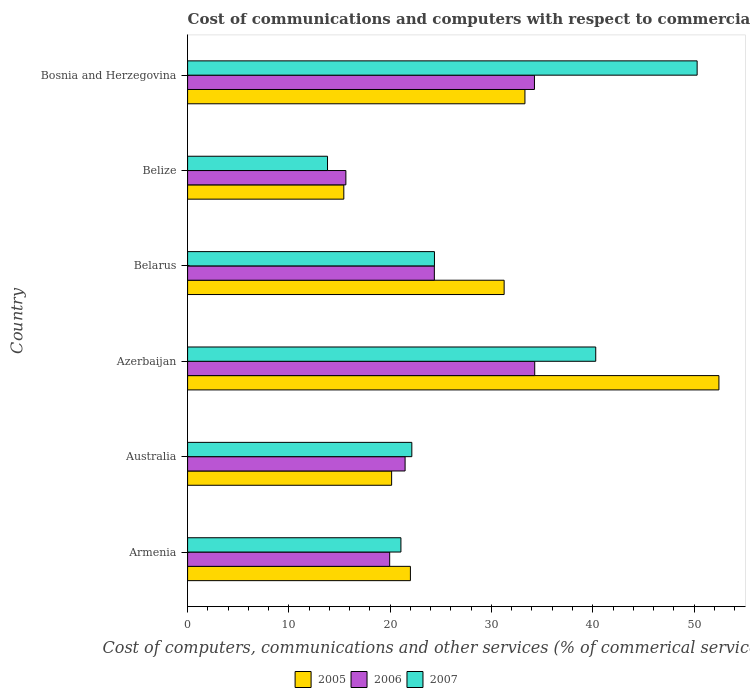How many groups of bars are there?
Offer a terse response. 6. Are the number of bars on each tick of the Y-axis equal?
Ensure brevity in your answer.  Yes. How many bars are there on the 5th tick from the bottom?
Your answer should be very brief. 3. What is the label of the 2nd group of bars from the top?
Make the answer very short. Belize. What is the cost of communications and computers in 2007 in Azerbaijan?
Keep it short and to the point. 40.29. Across all countries, what is the maximum cost of communications and computers in 2006?
Give a very brief answer. 34.27. Across all countries, what is the minimum cost of communications and computers in 2005?
Provide a short and direct response. 15.42. In which country was the cost of communications and computers in 2007 maximum?
Provide a succinct answer. Bosnia and Herzegovina. In which country was the cost of communications and computers in 2006 minimum?
Offer a very short reply. Belize. What is the total cost of communications and computers in 2006 in the graph?
Provide a short and direct response. 149.92. What is the difference between the cost of communications and computers in 2006 in Belize and that in Bosnia and Herzegovina?
Provide a short and direct response. -18.62. What is the difference between the cost of communications and computers in 2005 in Belize and the cost of communications and computers in 2006 in Armenia?
Offer a very short reply. -4.53. What is the average cost of communications and computers in 2006 per country?
Provide a short and direct response. 24.99. What is the difference between the cost of communications and computers in 2007 and cost of communications and computers in 2006 in Armenia?
Keep it short and to the point. 1.11. In how many countries, is the cost of communications and computers in 2007 greater than 18 %?
Your answer should be very brief. 5. What is the ratio of the cost of communications and computers in 2006 in Armenia to that in Bosnia and Herzegovina?
Give a very brief answer. 0.58. What is the difference between the highest and the second highest cost of communications and computers in 2006?
Provide a short and direct response. 0.03. What is the difference between the highest and the lowest cost of communications and computers in 2006?
Make the answer very short. 18.64. What does the 1st bar from the top in Australia represents?
Your answer should be very brief. 2007. What does the 1st bar from the bottom in Bosnia and Herzegovina represents?
Offer a terse response. 2005. Is it the case that in every country, the sum of the cost of communications and computers in 2005 and cost of communications and computers in 2007 is greater than the cost of communications and computers in 2006?
Keep it short and to the point. Yes. How many countries are there in the graph?
Your answer should be very brief. 6. What is the difference between two consecutive major ticks on the X-axis?
Ensure brevity in your answer.  10. Does the graph contain any zero values?
Give a very brief answer. No. Where does the legend appear in the graph?
Keep it short and to the point. Bottom center. What is the title of the graph?
Your answer should be very brief. Cost of communications and computers with respect to commercial service exports. Does "1963" appear as one of the legend labels in the graph?
Offer a terse response. No. What is the label or title of the X-axis?
Give a very brief answer. Cost of computers, communications and other services (% of commerical service exports). What is the label or title of the Y-axis?
Provide a short and direct response. Country. What is the Cost of computers, communications and other services (% of commerical service exports) in 2005 in Armenia?
Give a very brief answer. 22. What is the Cost of computers, communications and other services (% of commerical service exports) in 2006 in Armenia?
Your response must be concise. 19.95. What is the Cost of computers, communications and other services (% of commerical service exports) in 2007 in Armenia?
Ensure brevity in your answer.  21.06. What is the Cost of computers, communications and other services (% of commerical service exports) of 2005 in Australia?
Make the answer very short. 20.14. What is the Cost of computers, communications and other services (% of commerical service exports) in 2006 in Australia?
Give a very brief answer. 21.47. What is the Cost of computers, communications and other services (% of commerical service exports) in 2007 in Australia?
Provide a short and direct response. 22.14. What is the Cost of computers, communications and other services (% of commerical service exports) of 2005 in Azerbaijan?
Provide a short and direct response. 52.45. What is the Cost of computers, communications and other services (% of commerical service exports) of 2006 in Azerbaijan?
Make the answer very short. 34.27. What is the Cost of computers, communications and other services (% of commerical service exports) of 2007 in Azerbaijan?
Offer a terse response. 40.29. What is the Cost of computers, communications and other services (% of commerical service exports) in 2005 in Belarus?
Keep it short and to the point. 31.25. What is the Cost of computers, communications and other services (% of commerical service exports) in 2006 in Belarus?
Give a very brief answer. 24.36. What is the Cost of computers, communications and other services (% of commerical service exports) of 2007 in Belarus?
Your response must be concise. 24.37. What is the Cost of computers, communications and other services (% of commerical service exports) of 2005 in Belize?
Offer a terse response. 15.42. What is the Cost of computers, communications and other services (% of commerical service exports) in 2006 in Belize?
Keep it short and to the point. 15.63. What is the Cost of computers, communications and other services (% of commerical service exports) in 2007 in Belize?
Offer a terse response. 13.81. What is the Cost of computers, communications and other services (% of commerical service exports) in 2005 in Bosnia and Herzegovina?
Give a very brief answer. 33.3. What is the Cost of computers, communications and other services (% of commerical service exports) of 2006 in Bosnia and Herzegovina?
Your answer should be compact. 34.24. What is the Cost of computers, communications and other services (% of commerical service exports) of 2007 in Bosnia and Herzegovina?
Provide a succinct answer. 50.3. Across all countries, what is the maximum Cost of computers, communications and other services (% of commerical service exports) of 2005?
Keep it short and to the point. 52.45. Across all countries, what is the maximum Cost of computers, communications and other services (% of commerical service exports) of 2006?
Provide a succinct answer. 34.27. Across all countries, what is the maximum Cost of computers, communications and other services (% of commerical service exports) of 2007?
Provide a succinct answer. 50.3. Across all countries, what is the minimum Cost of computers, communications and other services (% of commerical service exports) in 2005?
Offer a very short reply. 15.42. Across all countries, what is the minimum Cost of computers, communications and other services (% of commerical service exports) of 2006?
Make the answer very short. 15.63. Across all countries, what is the minimum Cost of computers, communications and other services (% of commerical service exports) of 2007?
Your answer should be very brief. 13.81. What is the total Cost of computers, communications and other services (% of commerical service exports) in 2005 in the graph?
Your response must be concise. 174.57. What is the total Cost of computers, communications and other services (% of commerical service exports) of 2006 in the graph?
Your response must be concise. 149.92. What is the total Cost of computers, communications and other services (% of commerical service exports) of 2007 in the graph?
Provide a short and direct response. 171.98. What is the difference between the Cost of computers, communications and other services (% of commerical service exports) of 2005 in Armenia and that in Australia?
Offer a terse response. 1.85. What is the difference between the Cost of computers, communications and other services (% of commerical service exports) in 2006 in Armenia and that in Australia?
Ensure brevity in your answer.  -1.52. What is the difference between the Cost of computers, communications and other services (% of commerical service exports) of 2007 in Armenia and that in Australia?
Keep it short and to the point. -1.08. What is the difference between the Cost of computers, communications and other services (% of commerical service exports) of 2005 in Armenia and that in Azerbaijan?
Offer a terse response. -30.46. What is the difference between the Cost of computers, communications and other services (% of commerical service exports) of 2006 in Armenia and that in Azerbaijan?
Provide a succinct answer. -14.32. What is the difference between the Cost of computers, communications and other services (% of commerical service exports) in 2007 in Armenia and that in Azerbaijan?
Your answer should be very brief. -19.23. What is the difference between the Cost of computers, communications and other services (% of commerical service exports) of 2005 in Armenia and that in Belarus?
Your answer should be very brief. -9.25. What is the difference between the Cost of computers, communications and other services (% of commerical service exports) of 2006 in Armenia and that in Belarus?
Offer a very short reply. -4.41. What is the difference between the Cost of computers, communications and other services (% of commerical service exports) in 2007 in Armenia and that in Belarus?
Your answer should be compact. -3.31. What is the difference between the Cost of computers, communications and other services (% of commerical service exports) of 2005 in Armenia and that in Belize?
Give a very brief answer. 6.57. What is the difference between the Cost of computers, communications and other services (% of commerical service exports) in 2006 in Armenia and that in Belize?
Provide a short and direct response. 4.32. What is the difference between the Cost of computers, communications and other services (% of commerical service exports) in 2007 in Armenia and that in Belize?
Provide a short and direct response. 7.25. What is the difference between the Cost of computers, communications and other services (% of commerical service exports) of 2005 in Armenia and that in Bosnia and Herzegovina?
Keep it short and to the point. -11.31. What is the difference between the Cost of computers, communications and other services (% of commerical service exports) of 2006 in Armenia and that in Bosnia and Herzegovina?
Your answer should be very brief. -14.29. What is the difference between the Cost of computers, communications and other services (% of commerical service exports) in 2007 in Armenia and that in Bosnia and Herzegovina?
Give a very brief answer. -29.24. What is the difference between the Cost of computers, communications and other services (% of commerical service exports) of 2005 in Australia and that in Azerbaijan?
Provide a short and direct response. -32.31. What is the difference between the Cost of computers, communications and other services (% of commerical service exports) of 2006 in Australia and that in Azerbaijan?
Provide a succinct answer. -12.8. What is the difference between the Cost of computers, communications and other services (% of commerical service exports) in 2007 in Australia and that in Azerbaijan?
Keep it short and to the point. -18.16. What is the difference between the Cost of computers, communications and other services (% of commerical service exports) in 2005 in Australia and that in Belarus?
Your answer should be very brief. -11.11. What is the difference between the Cost of computers, communications and other services (% of commerical service exports) of 2006 in Australia and that in Belarus?
Provide a succinct answer. -2.89. What is the difference between the Cost of computers, communications and other services (% of commerical service exports) of 2007 in Australia and that in Belarus?
Give a very brief answer. -2.23. What is the difference between the Cost of computers, communications and other services (% of commerical service exports) of 2005 in Australia and that in Belize?
Keep it short and to the point. 4.72. What is the difference between the Cost of computers, communications and other services (% of commerical service exports) in 2006 in Australia and that in Belize?
Your response must be concise. 5.85. What is the difference between the Cost of computers, communications and other services (% of commerical service exports) of 2007 in Australia and that in Belize?
Provide a succinct answer. 8.32. What is the difference between the Cost of computers, communications and other services (% of commerical service exports) in 2005 in Australia and that in Bosnia and Herzegovina?
Give a very brief answer. -13.16. What is the difference between the Cost of computers, communications and other services (% of commerical service exports) of 2006 in Australia and that in Bosnia and Herzegovina?
Provide a succinct answer. -12.77. What is the difference between the Cost of computers, communications and other services (% of commerical service exports) of 2007 in Australia and that in Bosnia and Herzegovina?
Provide a succinct answer. -28.17. What is the difference between the Cost of computers, communications and other services (% of commerical service exports) in 2005 in Azerbaijan and that in Belarus?
Your answer should be compact. 21.2. What is the difference between the Cost of computers, communications and other services (% of commerical service exports) in 2006 in Azerbaijan and that in Belarus?
Your response must be concise. 9.91. What is the difference between the Cost of computers, communications and other services (% of commerical service exports) in 2007 in Azerbaijan and that in Belarus?
Keep it short and to the point. 15.92. What is the difference between the Cost of computers, communications and other services (% of commerical service exports) of 2005 in Azerbaijan and that in Belize?
Your response must be concise. 37.03. What is the difference between the Cost of computers, communications and other services (% of commerical service exports) in 2006 in Azerbaijan and that in Belize?
Keep it short and to the point. 18.64. What is the difference between the Cost of computers, communications and other services (% of commerical service exports) of 2007 in Azerbaijan and that in Belize?
Make the answer very short. 26.48. What is the difference between the Cost of computers, communications and other services (% of commerical service exports) of 2005 in Azerbaijan and that in Bosnia and Herzegovina?
Your answer should be compact. 19.15. What is the difference between the Cost of computers, communications and other services (% of commerical service exports) of 2006 in Azerbaijan and that in Bosnia and Herzegovina?
Make the answer very short. 0.03. What is the difference between the Cost of computers, communications and other services (% of commerical service exports) of 2007 in Azerbaijan and that in Bosnia and Herzegovina?
Give a very brief answer. -10.01. What is the difference between the Cost of computers, communications and other services (% of commerical service exports) in 2005 in Belarus and that in Belize?
Make the answer very short. 15.83. What is the difference between the Cost of computers, communications and other services (% of commerical service exports) of 2006 in Belarus and that in Belize?
Offer a terse response. 8.73. What is the difference between the Cost of computers, communications and other services (% of commerical service exports) in 2007 in Belarus and that in Belize?
Provide a succinct answer. 10.56. What is the difference between the Cost of computers, communications and other services (% of commerical service exports) of 2005 in Belarus and that in Bosnia and Herzegovina?
Your answer should be compact. -2.05. What is the difference between the Cost of computers, communications and other services (% of commerical service exports) of 2006 in Belarus and that in Bosnia and Herzegovina?
Ensure brevity in your answer.  -9.88. What is the difference between the Cost of computers, communications and other services (% of commerical service exports) of 2007 in Belarus and that in Bosnia and Herzegovina?
Provide a short and direct response. -25.93. What is the difference between the Cost of computers, communications and other services (% of commerical service exports) of 2005 in Belize and that in Bosnia and Herzegovina?
Give a very brief answer. -17.88. What is the difference between the Cost of computers, communications and other services (% of commerical service exports) of 2006 in Belize and that in Bosnia and Herzegovina?
Your answer should be very brief. -18.62. What is the difference between the Cost of computers, communications and other services (% of commerical service exports) in 2007 in Belize and that in Bosnia and Herzegovina?
Offer a very short reply. -36.49. What is the difference between the Cost of computers, communications and other services (% of commerical service exports) of 2005 in Armenia and the Cost of computers, communications and other services (% of commerical service exports) of 2006 in Australia?
Provide a succinct answer. 0.52. What is the difference between the Cost of computers, communications and other services (% of commerical service exports) of 2005 in Armenia and the Cost of computers, communications and other services (% of commerical service exports) of 2007 in Australia?
Make the answer very short. -0.14. What is the difference between the Cost of computers, communications and other services (% of commerical service exports) in 2006 in Armenia and the Cost of computers, communications and other services (% of commerical service exports) in 2007 in Australia?
Give a very brief answer. -2.19. What is the difference between the Cost of computers, communications and other services (% of commerical service exports) in 2005 in Armenia and the Cost of computers, communications and other services (% of commerical service exports) in 2006 in Azerbaijan?
Provide a succinct answer. -12.27. What is the difference between the Cost of computers, communications and other services (% of commerical service exports) in 2005 in Armenia and the Cost of computers, communications and other services (% of commerical service exports) in 2007 in Azerbaijan?
Offer a terse response. -18.3. What is the difference between the Cost of computers, communications and other services (% of commerical service exports) in 2006 in Armenia and the Cost of computers, communications and other services (% of commerical service exports) in 2007 in Azerbaijan?
Provide a succinct answer. -20.34. What is the difference between the Cost of computers, communications and other services (% of commerical service exports) in 2005 in Armenia and the Cost of computers, communications and other services (% of commerical service exports) in 2006 in Belarus?
Your answer should be very brief. -2.36. What is the difference between the Cost of computers, communications and other services (% of commerical service exports) in 2005 in Armenia and the Cost of computers, communications and other services (% of commerical service exports) in 2007 in Belarus?
Offer a terse response. -2.37. What is the difference between the Cost of computers, communications and other services (% of commerical service exports) of 2006 in Armenia and the Cost of computers, communications and other services (% of commerical service exports) of 2007 in Belarus?
Provide a succinct answer. -4.42. What is the difference between the Cost of computers, communications and other services (% of commerical service exports) of 2005 in Armenia and the Cost of computers, communications and other services (% of commerical service exports) of 2006 in Belize?
Keep it short and to the point. 6.37. What is the difference between the Cost of computers, communications and other services (% of commerical service exports) in 2005 in Armenia and the Cost of computers, communications and other services (% of commerical service exports) in 2007 in Belize?
Keep it short and to the point. 8.18. What is the difference between the Cost of computers, communications and other services (% of commerical service exports) in 2006 in Armenia and the Cost of computers, communications and other services (% of commerical service exports) in 2007 in Belize?
Make the answer very short. 6.14. What is the difference between the Cost of computers, communications and other services (% of commerical service exports) of 2005 in Armenia and the Cost of computers, communications and other services (% of commerical service exports) of 2006 in Bosnia and Herzegovina?
Provide a succinct answer. -12.25. What is the difference between the Cost of computers, communications and other services (% of commerical service exports) of 2005 in Armenia and the Cost of computers, communications and other services (% of commerical service exports) of 2007 in Bosnia and Herzegovina?
Your answer should be compact. -28.31. What is the difference between the Cost of computers, communications and other services (% of commerical service exports) of 2006 in Armenia and the Cost of computers, communications and other services (% of commerical service exports) of 2007 in Bosnia and Herzegovina?
Make the answer very short. -30.35. What is the difference between the Cost of computers, communications and other services (% of commerical service exports) in 2005 in Australia and the Cost of computers, communications and other services (% of commerical service exports) in 2006 in Azerbaijan?
Your response must be concise. -14.13. What is the difference between the Cost of computers, communications and other services (% of commerical service exports) of 2005 in Australia and the Cost of computers, communications and other services (% of commerical service exports) of 2007 in Azerbaijan?
Keep it short and to the point. -20.15. What is the difference between the Cost of computers, communications and other services (% of commerical service exports) of 2006 in Australia and the Cost of computers, communications and other services (% of commerical service exports) of 2007 in Azerbaijan?
Give a very brief answer. -18.82. What is the difference between the Cost of computers, communications and other services (% of commerical service exports) of 2005 in Australia and the Cost of computers, communications and other services (% of commerical service exports) of 2006 in Belarus?
Provide a short and direct response. -4.22. What is the difference between the Cost of computers, communications and other services (% of commerical service exports) of 2005 in Australia and the Cost of computers, communications and other services (% of commerical service exports) of 2007 in Belarus?
Keep it short and to the point. -4.23. What is the difference between the Cost of computers, communications and other services (% of commerical service exports) in 2006 in Australia and the Cost of computers, communications and other services (% of commerical service exports) in 2007 in Belarus?
Ensure brevity in your answer.  -2.9. What is the difference between the Cost of computers, communications and other services (% of commerical service exports) in 2005 in Australia and the Cost of computers, communications and other services (% of commerical service exports) in 2006 in Belize?
Keep it short and to the point. 4.52. What is the difference between the Cost of computers, communications and other services (% of commerical service exports) of 2005 in Australia and the Cost of computers, communications and other services (% of commerical service exports) of 2007 in Belize?
Your answer should be compact. 6.33. What is the difference between the Cost of computers, communications and other services (% of commerical service exports) of 2006 in Australia and the Cost of computers, communications and other services (% of commerical service exports) of 2007 in Belize?
Provide a succinct answer. 7.66. What is the difference between the Cost of computers, communications and other services (% of commerical service exports) of 2005 in Australia and the Cost of computers, communications and other services (% of commerical service exports) of 2006 in Bosnia and Herzegovina?
Ensure brevity in your answer.  -14.1. What is the difference between the Cost of computers, communications and other services (% of commerical service exports) of 2005 in Australia and the Cost of computers, communications and other services (% of commerical service exports) of 2007 in Bosnia and Herzegovina?
Offer a terse response. -30.16. What is the difference between the Cost of computers, communications and other services (% of commerical service exports) of 2006 in Australia and the Cost of computers, communications and other services (% of commerical service exports) of 2007 in Bosnia and Herzegovina?
Provide a succinct answer. -28.83. What is the difference between the Cost of computers, communications and other services (% of commerical service exports) of 2005 in Azerbaijan and the Cost of computers, communications and other services (% of commerical service exports) of 2006 in Belarus?
Provide a succinct answer. 28.1. What is the difference between the Cost of computers, communications and other services (% of commerical service exports) in 2005 in Azerbaijan and the Cost of computers, communications and other services (% of commerical service exports) in 2007 in Belarus?
Your answer should be compact. 28.08. What is the difference between the Cost of computers, communications and other services (% of commerical service exports) of 2006 in Azerbaijan and the Cost of computers, communications and other services (% of commerical service exports) of 2007 in Belarus?
Your answer should be compact. 9.9. What is the difference between the Cost of computers, communications and other services (% of commerical service exports) in 2005 in Azerbaijan and the Cost of computers, communications and other services (% of commerical service exports) in 2006 in Belize?
Provide a short and direct response. 36.83. What is the difference between the Cost of computers, communications and other services (% of commerical service exports) of 2005 in Azerbaijan and the Cost of computers, communications and other services (% of commerical service exports) of 2007 in Belize?
Provide a short and direct response. 38.64. What is the difference between the Cost of computers, communications and other services (% of commerical service exports) of 2006 in Azerbaijan and the Cost of computers, communications and other services (% of commerical service exports) of 2007 in Belize?
Your answer should be compact. 20.46. What is the difference between the Cost of computers, communications and other services (% of commerical service exports) in 2005 in Azerbaijan and the Cost of computers, communications and other services (% of commerical service exports) in 2006 in Bosnia and Herzegovina?
Your answer should be very brief. 18.21. What is the difference between the Cost of computers, communications and other services (% of commerical service exports) in 2005 in Azerbaijan and the Cost of computers, communications and other services (% of commerical service exports) in 2007 in Bosnia and Herzegovina?
Your answer should be compact. 2.15. What is the difference between the Cost of computers, communications and other services (% of commerical service exports) of 2006 in Azerbaijan and the Cost of computers, communications and other services (% of commerical service exports) of 2007 in Bosnia and Herzegovina?
Make the answer very short. -16.04. What is the difference between the Cost of computers, communications and other services (% of commerical service exports) in 2005 in Belarus and the Cost of computers, communications and other services (% of commerical service exports) in 2006 in Belize?
Keep it short and to the point. 15.62. What is the difference between the Cost of computers, communications and other services (% of commerical service exports) in 2005 in Belarus and the Cost of computers, communications and other services (% of commerical service exports) in 2007 in Belize?
Your response must be concise. 17.44. What is the difference between the Cost of computers, communications and other services (% of commerical service exports) in 2006 in Belarus and the Cost of computers, communications and other services (% of commerical service exports) in 2007 in Belize?
Offer a very short reply. 10.55. What is the difference between the Cost of computers, communications and other services (% of commerical service exports) of 2005 in Belarus and the Cost of computers, communications and other services (% of commerical service exports) of 2006 in Bosnia and Herzegovina?
Give a very brief answer. -2.99. What is the difference between the Cost of computers, communications and other services (% of commerical service exports) of 2005 in Belarus and the Cost of computers, communications and other services (% of commerical service exports) of 2007 in Bosnia and Herzegovina?
Provide a short and direct response. -19.05. What is the difference between the Cost of computers, communications and other services (% of commerical service exports) of 2006 in Belarus and the Cost of computers, communications and other services (% of commerical service exports) of 2007 in Bosnia and Herzegovina?
Provide a succinct answer. -25.95. What is the difference between the Cost of computers, communications and other services (% of commerical service exports) in 2005 in Belize and the Cost of computers, communications and other services (% of commerical service exports) in 2006 in Bosnia and Herzegovina?
Ensure brevity in your answer.  -18.82. What is the difference between the Cost of computers, communications and other services (% of commerical service exports) of 2005 in Belize and the Cost of computers, communications and other services (% of commerical service exports) of 2007 in Bosnia and Herzegovina?
Provide a short and direct response. -34.88. What is the difference between the Cost of computers, communications and other services (% of commerical service exports) in 2006 in Belize and the Cost of computers, communications and other services (% of commerical service exports) in 2007 in Bosnia and Herzegovina?
Keep it short and to the point. -34.68. What is the average Cost of computers, communications and other services (% of commerical service exports) of 2005 per country?
Provide a short and direct response. 29.09. What is the average Cost of computers, communications and other services (% of commerical service exports) in 2006 per country?
Offer a terse response. 24.99. What is the average Cost of computers, communications and other services (% of commerical service exports) in 2007 per country?
Give a very brief answer. 28.66. What is the difference between the Cost of computers, communications and other services (% of commerical service exports) in 2005 and Cost of computers, communications and other services (% of commerical service exports) in 2006 in Armenia?
Ensure brevity in your answer.  2.05. What is the difference between the Cost of computers, communications and other services (% of commerical service exports) of 2005 and Cost of computers, communications and other services (% of commerical service exports) of 2007 in Armenia?
Provide a succinct answer. 0.94. What is the difference between the Cost of computers, communications and other services (% of commerical service exports) of 2006 and Cost of computers, communications and other services (% of commerical service exports) of 2007 in Armenia?
Offer a very short reply. -1.11. What is the difference between the Cost of computers, communications and other services (% of commerical service exports) of 2005 and Cost of computers, communications and other services (% of commerical service exports) of 2006 in Australia?
Your response must be concise. -1.33. What is the difference between the Cost of computers, communications and other services (% of commerical service exports) in 2005 and Cost of computers, communications and other services (% of commerical service exports) in 2007 in Australia?
Your response must be concise. -1.99. What is the difference between the Cost of computers, communications and other services (% of commerical service exports) in 2006 and Cost of computers, communications and other services (% of commerical service exports) in 2007 in Australia?
Give a very brief answer. -0.66. What is the difference between the Cost of computers, communications and other services (% of commerical service exports) in 2005 and Cost of computers, communications and other services (% of commerical service exports) in 2006 in Azerbaijan?
Your response must be concise. 18.19. What is the difference between the Cost of computers, communications and other services (% of commerical service exports) in 2005 and Cost of computers, communications and other services (% of commerical service exports) in 2007 in Azerbaijan?
Ensure brevity in your answer.  12.16. What is the difference between the Cost of computers, communications and other services (% of commerical service exports) in 2006 and Cost of computers, communications and other services (% of commerical service exports) in 2007 in Azerbaijan?
Keep it short and to the point. -6.02. What is the difference between the Cost of computers, communications and other services (% of commerical service exports) of 2005 and Cost of computers, communications and other services (% of commerical service exports) of 2006 in Belarus?
Offer a terse response. 6.89. What is the difference between the Cost of computers, communications and other services (% of commerical service exports) of 2005 and Cost of computers, communications and other services (% of commerical service exports) of 2007 in Belarus?
Provide a succinct answer. 6.88. What is the difference between the Cost of computers, communications and other services (% of commerical service exports) of 2006 and Cost of computers, communications and other services (% of commerical service exports) of 2007 in Belarus?
Give a very brief answer. -0.01. What is the difference between the Cost of computers, communications and other services (% of commerical service exports) in 2005 and Cost of computers, communications and other services (% of commerical service exports) in 2006 in Belize?
Provide a short and direct response. -0.2. What is the difference between the Cost of computers, communications and other services (% of commerical service exports) of 2005 and Cost of computers, communications and other services (% of commerical service exports) of 2007 in Belize?
Provide a short and direct response. 1.61. What is the difference between the Cost of computers, communications and other services (% of commerical service exports) of 2006 and Cost of computers, communications and other services (% of commerical service exports) of 2007 in Belize?
Give a very brief answer. 1.81. What is the difference between the Cost of computers, communications and other services (% of commerical service exports) in 2005 and Cost of computers, communications and other services (% of commerical service exports) in 2006 in Bosnia and Herzegovina?
Give a very brief answer. -0.94. What is the difference between the Cost of computers, communications and other services (% of commerical service exports) in 2005 and Cost of computers, communications and other services (% of commerical service exports) in 2007 in Bosnia and Herzegovina?
Your response must be concise. -17. What is the difference between the Cost of computers, communications and other services (% of commerical service exports) in 2006 and Cost of computers, communications and other services (% of commerical service exports) in 2007 in Bosnia and Herzegovina?
Offer a terse response. -16.06. What is the ratio of the Cost of computers, communications and other services (% of commerical service exports) of 2005 in Armenia to that in Australia?
Give a very brief answer. 1.09. What is the ratio of the Cost of computers, communications and other services (% of commerical service exports) in 2006 in Armenia to that in Australia?
Provide a succinct answer. 0.93. What is the ratio of the Cost of computers, communications and other services (% of commerical service exports) in 2007 in Armenia to that in Australia?
Make the answer very short. 0.95. What is the ratio of the Cost of computers, communications and other services (% of commerical service exports) of 2005 in Armenia to that in Azerbaijan?
Your answer should be compact. 0.42. What is the ratio of the Cost of computers, communications and other services (% of commerical service exports) in 2006 in Armenia to that in Azerbaijan?
Your answer should be compact. 0.58. What is the ratio of the Cost of computers, communications and other services (% of commerical service exports) of 2007 in Armenia to that in Azerbaijan?
Make the answer very short. 0.52. What is the ratio of the Cost of computers, communications and other services (% of commerical service exports) of 2005 in Armenia to that in Belarus?
Keep it short and to the point. 0.7. What is the ratio of the Cost of computers, communications and other services (% of commerical service exports) of 2006 in Armenia to that in Belarus?
Ensure brevity in your answer.  0.82. What is the ratio of the Cost of computers, communications and other services (% of commerical service exports) of 2007 in Armenia to that in Belarus?
Ensure brevity in your answer.  0.86. What is the ratio of the Cost of computers, communications and other services (% of commerical service exports) in 2005 in Armenia to that in Belize?
Keep it short and to the point. 1.43. What is the ratio of the Cost of computers, communications and other services (% of commerical service exports) in 2006 in Armenia to that in Belize?
Your answer should be very brief. 1.28. What is the ratio of the Cost of computers, communications and other services (% of commerical service exports) of 2007 in Armenia to that in Belize?
Offer a very short reply. 1.52. What is the ratio of the Cost of computers, communications and other services (% of commerical service exports) in 2005 in Armenia to that in Bosnia and Herzegovina?
Provide a short and direct response. 0.66. What is the ratio of the Cost of computers, communications and other services (% of commerical service exports) in 2006 in Armenia to that in Bosnia and Herzegovina?
Your answer should be compact. 0.58. What is the ratio of the Cost of computers, communications and other services (% of commerical service exports) in 2007 in Armenia to that in Bosnia and Herzegovina?
Your answer should be very brief. 0.42. What is the ratio of the Cost of computers, communications and other services (% of commerical service exports) of 2005 in Australia to that in Azerbaijan?
Offer a very short reply. 0.38. What is the ratio of the Cost of computers, communications and other services (% of commerical service exports) of 2006 in Australia to that in Azerbaijan?
Your response must be concise. 0.63. What is the ratio of the Cost of computers, communications and other services (% of commerical service exports) of 2007 in Australia to that in Azerbaijan?
Provide a succinct answer. 0.55. What is the ratio of the Cost of computers, communications and other services (% of commerical service exports) in 2005 in Australia to that in Belarus?
Provide a succinct answer. 0.64. What is the ratio of the Cost of computers, communications and other services (% of commerical service exports) in 2006 in Australia to that in Belarus?
Offer a terse response. 0.88. What is the ratio of the Cost of computers, communications and other services (% of commerical service exports) of 2007 in Australia to that in Belarus?
Ensure brevity in your answer.  0.91. What is the ratio of the Cost of computers, communications and other services (% of commerical service exports) in 2005 in Australia to that in Belize?
Give a very brief answer. 1.31. What is the ratio of the Cost of computers, communications and other services (% of commerical service exports) in 2006 in Australia to that in Belize?
Your response must be concise. 1.37. What is the ratio of the Cost of computers, communications and other services (% of commerical service exports) in 2007 in Australia to that in Belize?
Your answer should be very brief. 1.6. What is the ratio of the Cost of computers, communications and other services (% of commerical service exports) of 2005 in Australia to that in Bosnia and Herzegovina?
Offer a terse response. 0.6. What is the ratio of the Cost of computers, communications and other services (% of commerical service exports) of 2006 in Australia to that in Bosnia and Herzegovina?
Ensure brevity in your answer.  0.63. What is the ratio of the Cost of computers, communications and other services (% of commerical service exports) of 2007 in Australia to that in Bosnia and Herzegovina?
Offer a terse response. 0.44. What is the ratio of the Cost of computers, communications and other services (% of commerical service exports) in 2005 in Azerbaijan to that in Belarus?
Ensure brevity in your answer.  1.68. What is the ratio of the Cost of computers, communications and other services (% of commerical service exports) in 2006 in Azerbaijan to that in Belarus?
Provide a short and direct response. 1.41. What is the ratio of the Cost of computers, communications and other services (% of commerical service exports) in 2007 in Azerbaijan to that in Belarus?
Provide a succinct answer. 1.65. What is the ratio of the Cost of computers, communications and other services (% of commerical service exports) in 2005 in Azerbaijan to that in Belize?
Your response must be concise. 3.4. What is the ratio of the Cost of computers, communications and other services (% of commerical service exports) in 2006 in Azerbaijan to that in Belize?
Ensure brevity in your answer.  2.19. What is the ratio of the Cost of computers, communications and other services (% of commerical service exports) in 2007 in Azerbaijan to that in Belize?
Give a very brief answer. 2.92. What is the ratio of the Cost of computers, communications and other services (% of commerical service exports) in 2005 in Azerbaijan to that in Bosnia and Herzegovina?
Your response must be concise. 1.58. What is the ratio of the Cost of computers, communications and other services (% of commerical service exports) of 2006 in Azerbaijan to that in Bosnia and Herzegovina?
Give a very brief answer. 1. What is the ratio of the Cost of computers, communications and other services (% of commerical service exports) in 2007 in Azerbaijan to that in Bosnia and Herzegovina?
Ensure brevity in your answer.  0.8. What is the ratio of the Cost of computers, communications and other services (% of commerical service exports) in 2005 in Belarus to that in Belize?
Provide a succinct answer. 2.03. What is the ratio of the Cost of computers, communications and other services (% of commerical service exports) of 2006 in Belarus to that in Belize?
Provide a short and direct response. 1.56. What is the ratio of the Cost of computers, communications and other services (% of commerical service exports) of 2007 in Belarus to that in Belize?
Offer a terse response. 1.76. What is the ratio of the Cost of computers, communications and other services (% of commerical service exports) of 2005 in Belarus to that in Bosnia and Herzegovina?
Make the answer very short. 0.94. What is the ratio of the Cost of computers, communications and other services (% of commerical service exports) of 2006 in Belarus to that in Bosnia and Herzegovina?
Offer a terse response. 0.71. What is the ratio of the Cost of computers, communications and other services (% of commerical service exports) of 2007 in Belarus to that in Bosnia and Herzegovina?
Your answer should be very brief. 0.48. What is the ratio of the Cost of computers, communications and other services (% of commerical service exports) of 2005 in Belize to that in Bosnia and Herzegovina?
Offer a terse response. 0.46. What is the ratio of the Cost of computers, communications and other services (% of commerical service exports) of 2006 in Belize to that in Bosnia and Herzegovina?
Your answer should be compact. 0.46. What is the ratio of the Cost of computers, communications and other services (% of commerical service exports) of 2007 in Belize to that in Bosnia and Herzegovina?
Provide a succinct answer. 0.27. What is the difference between the highest and the second highest Cost of computers, communications and other services (% of commerical service exports) in 2005?
Your answer should be very brief. 19.15. What is the difference between the highest and the second highest Cost of computers, communications and other services (% of commerical service exports) of 2006?
Offer a terse response. 0.03. What is the difference between the highest and the second highest Cost of computers, communications and other services (% of commerical service exports) of 2007?
Keep it short and to the point. 10.01. What is the difference between the highest and the lowest Cost of computers, communications and other services (% of commerical service exports) in 2005?
Your answer should be compact. 37.03. What is the difference between the highest and the lowest Cost of computers, communications and other services (% of commerical service exports) in 2006?
Your response must be concise. 18.64. What is the difference between the highest and the lowest Cost of computers, communications and other services (% of commerical service exports) in 2007?
Your answer should be compact. 36.49. 